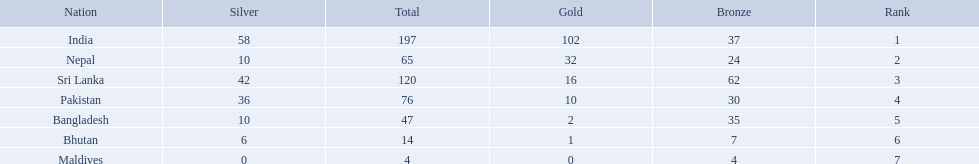Could you help me parse every detail presented in this table? {'header': ['Nation', 'Silver', 'Total', 'Gold', 'Bronze', 'Rank'], 'rows': [['India', '58', '197', '102', '37', '1'], ['Nepal', '10', '65', '32', '24', '2'], ['Sri Lanka', '42', '120', '16', '62', '3'], ['Pakistan', '36', '76', '10', '30', '4'], ['Bangladesh', '10', '47', '2', '35', '5'], ['Bhutan', '6', '14', '1', '7', '6'], ['Maldives', '0', '4', '0', '4', '7']]} What are the nations? India, Nepal, Sri Lanka, Pakistan, Bangladesh, Bhutan, Maldives. Of these, which one has earned the least amount of gold medals? Maldives. 